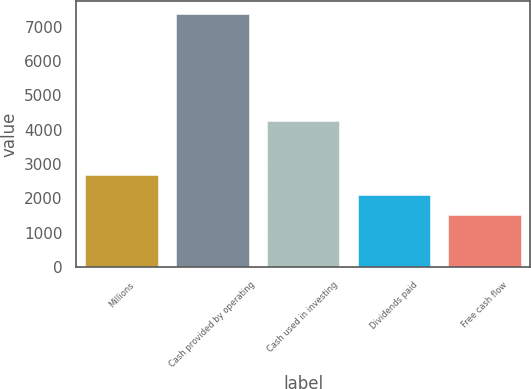Convert chart. <chart><loc_0><loc_0><loc_500><loc_500><bar_chart><fcel>Millions<fcel>Cash provided by operating<fcel>Cash used in investing<fcel>Dividends paid<fcel>Free cash flow<nl><fcel>2680.2<fcel>7385<fcel>4249<fcel>2092.1<fcel>1504<nl></chart> 